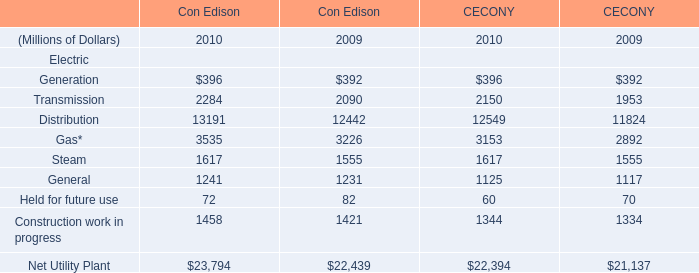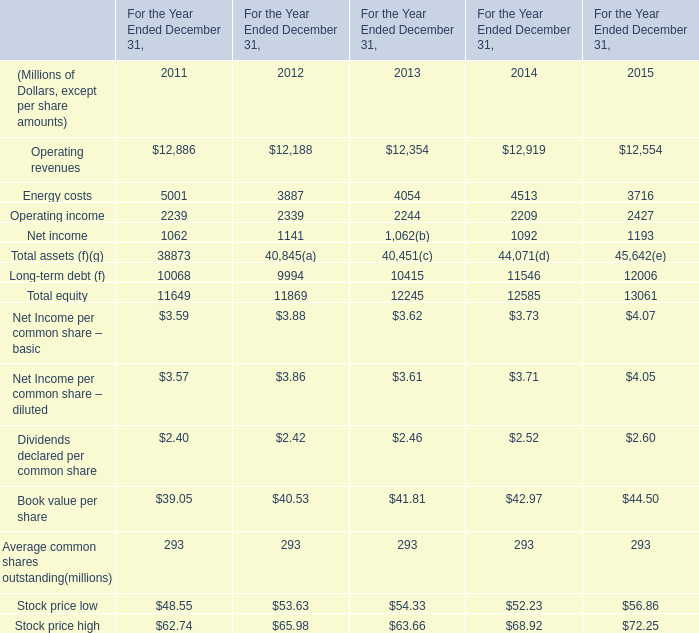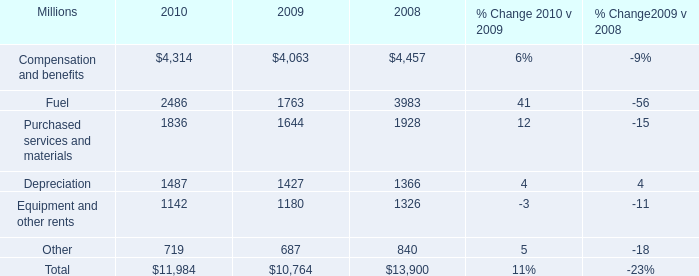What is the average amount of Transmission of CECONY 2010, and Energy costs of For the Year Ended December 31, 2014 ? 
Computations: ((2150.0 + 4513.0) / 2)
Answer: 3331.5. 